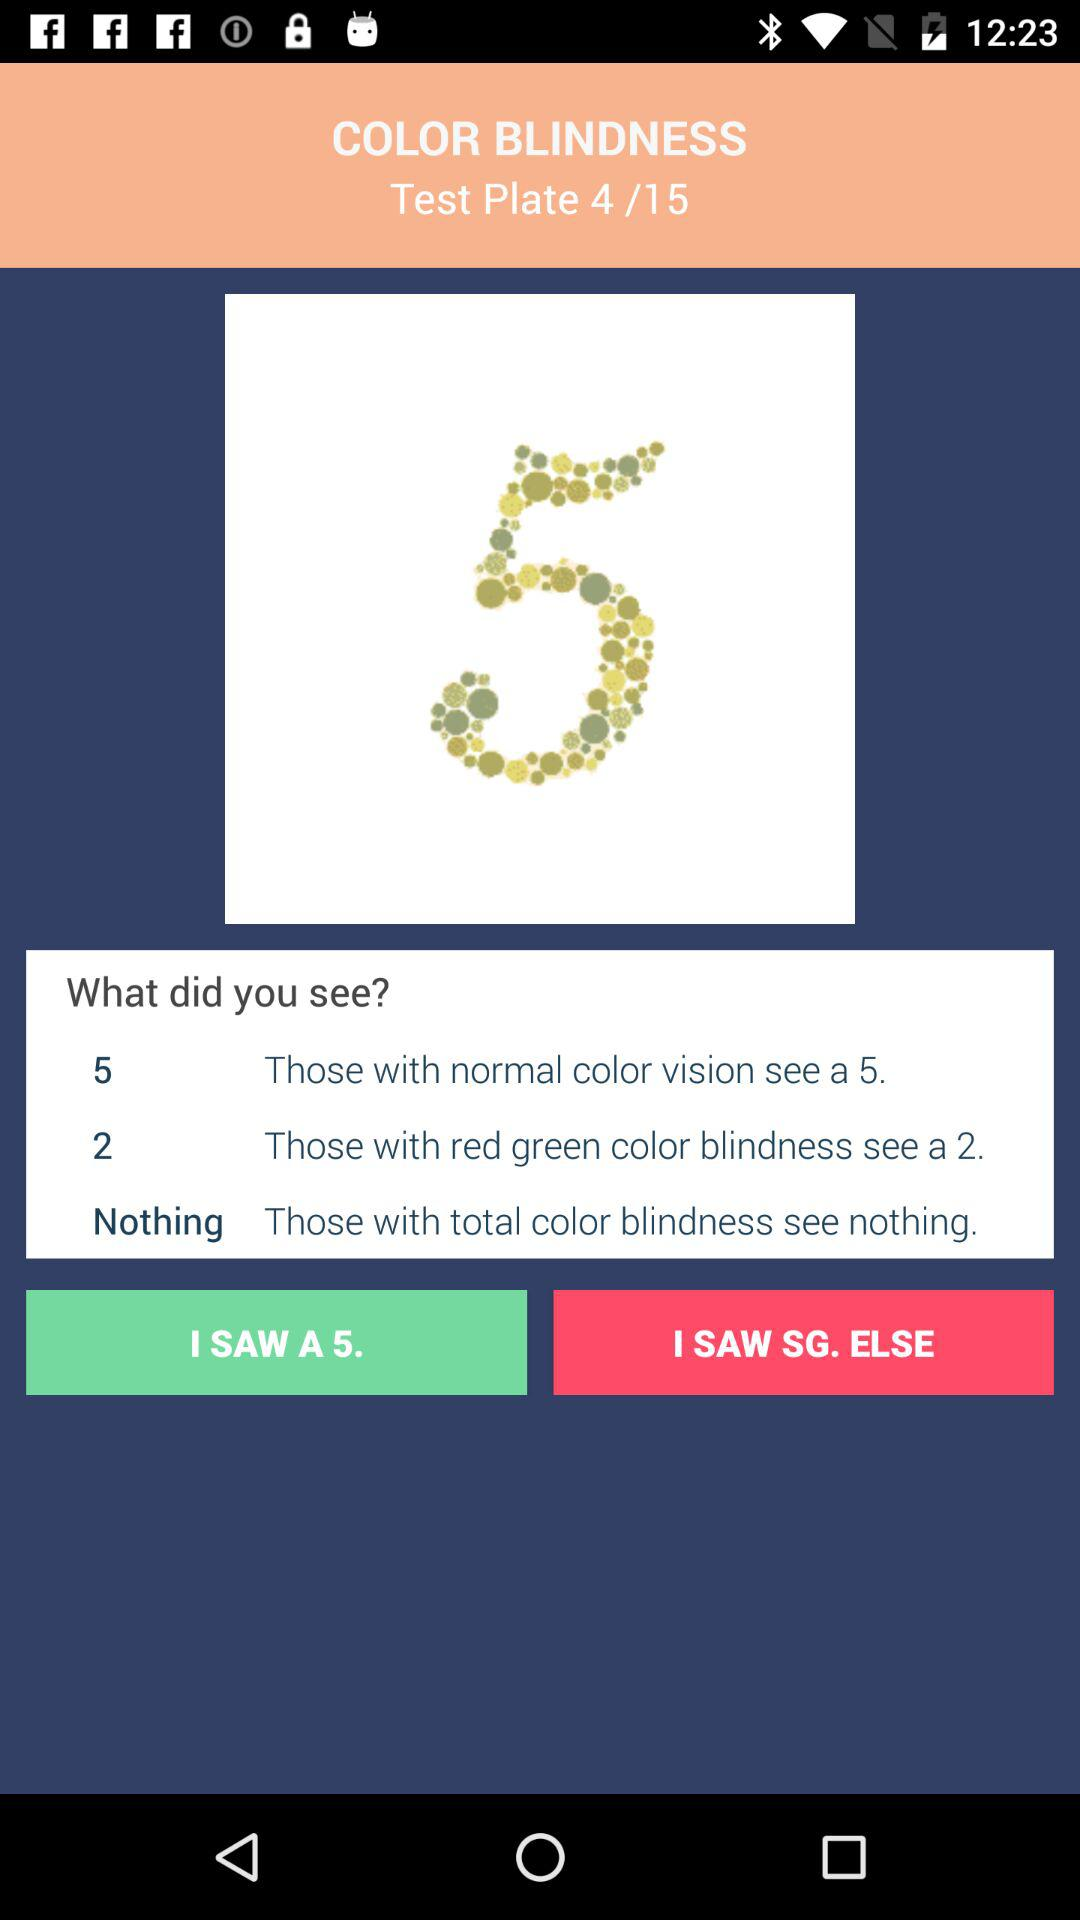How many more options are there for people with normal color vision than for people with red green color blindness?
Answer the question using a single word or phrase. 3 